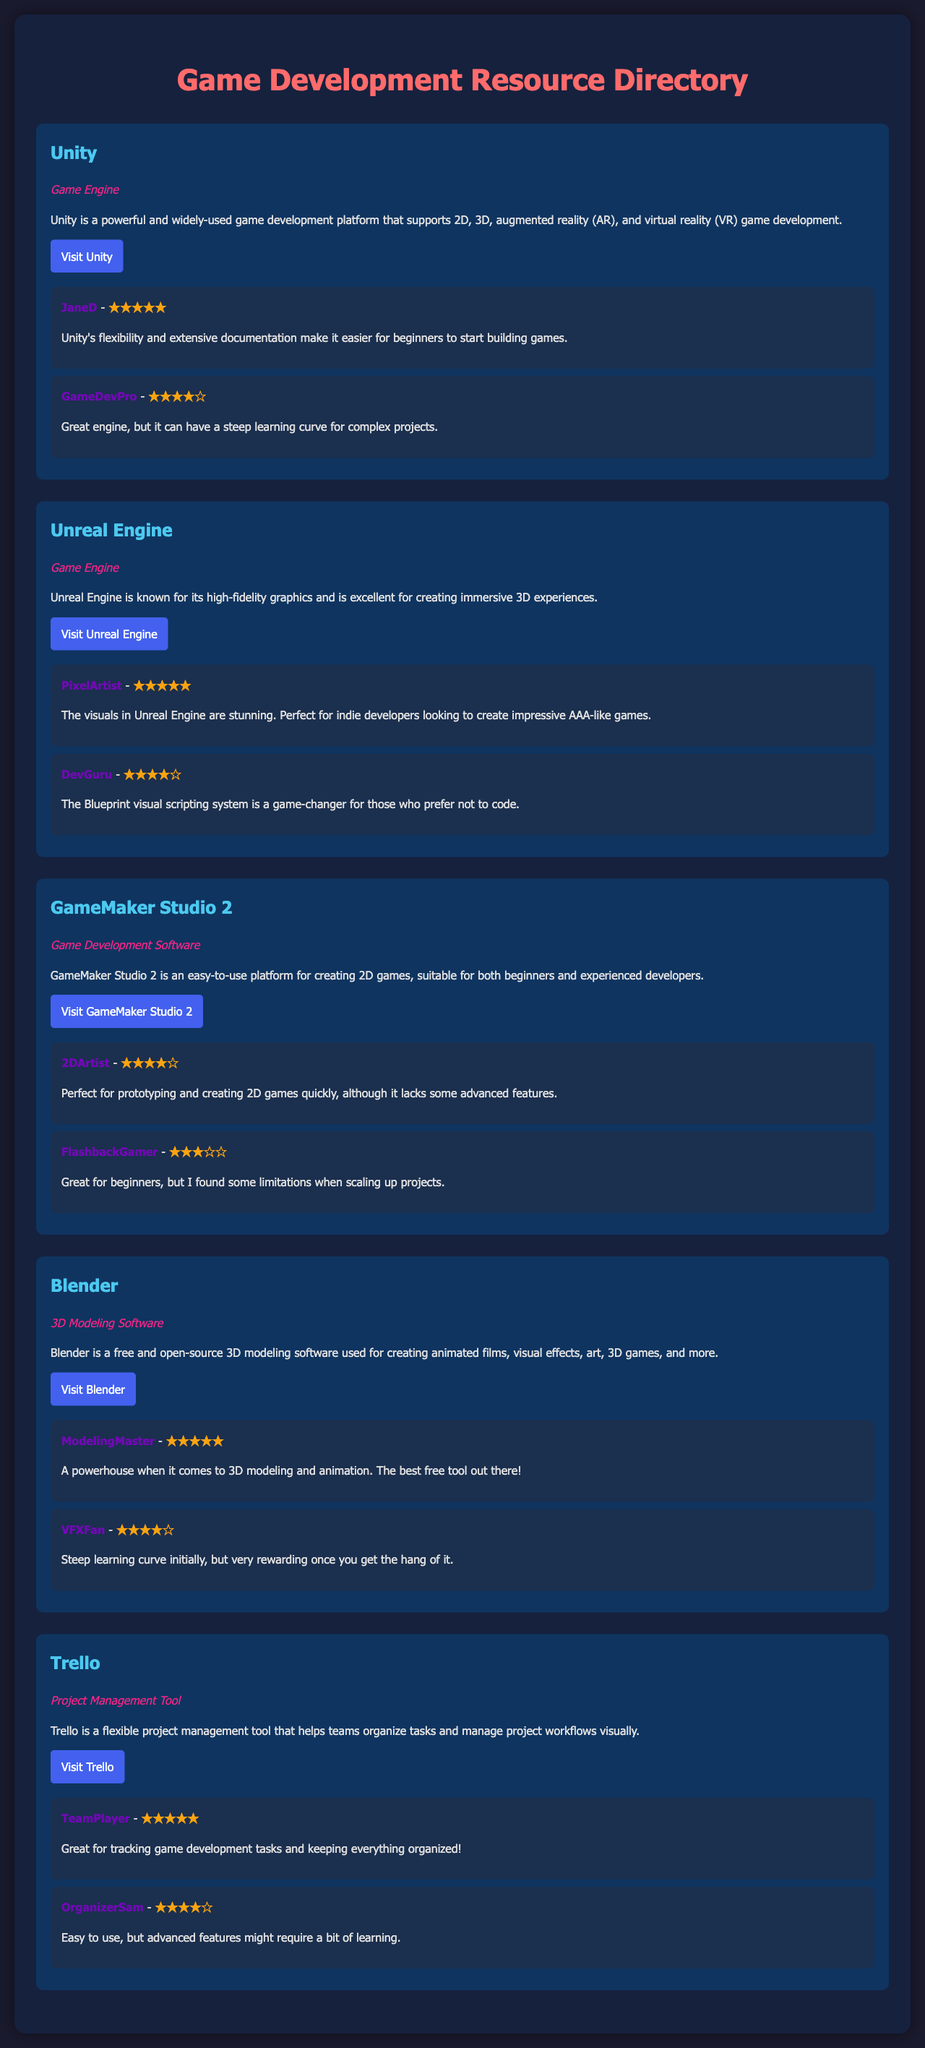What is the rating given by JaneD for Unity? JaneD rated Unity with five stars in her review.
Answer: ★★★★★ What type of software is GameMaker Studio 2? GameMaker Studio 2 is classified as Game Development Software in the document.
Answer: Game Development Software How many reviews are there for Blender? There are two reviews presented for Blender in the resource directory.
Answer: 2 What is the main advantage of using Unreal Engine according to PixelArtist? PixelArtist highlights the stunning visuals as a key advantage of using Unreal Engine.
Answer: Stunning visuals What platform is Trello associated with? Trello is mentioned as a Project Management Tool in the document.
Answer: Project Management Tool Which resource has a user named FlashbackGamer giving a review? FlashbackGamer provided a review for GameMaker Studio 2 indicating its limitations when scaling up projects.
Answer: GameMaker Studio 2 What is the website link for Unity? The document specifies the URL where Unity can be accessed.
Answer: https://unity.com/ How does the review by TeamPlayer describe Trello? TeamPlayer suggests that Trello is great for tracking game development tasks and organization.
Answer: Great for tracking game development tasks 